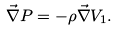<formula> <loc_0><loc_0><loc_500><loc_500>\vec { \nabla } P = - \rho \vec { \nabla } V _ { 1 } .</formula> 